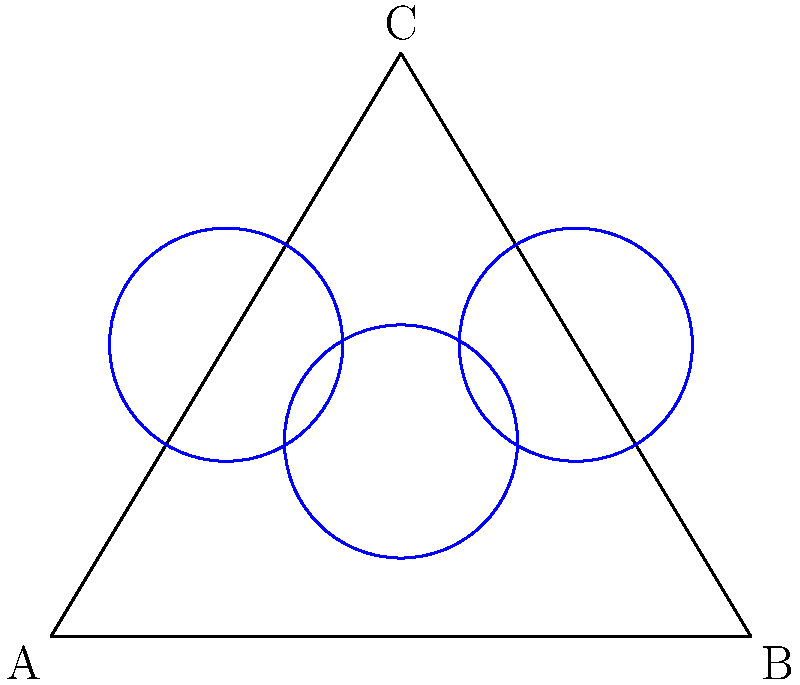In a software optimization problem, you need to place three identical circular processing units within an equilateral triangular server rack for maximum efficiency. Given that the side length of the triangular rack is 6 units, what is the maximum radius of each circular processing unit that can fit within the rack without overlapping? To solve this problem, we'll follow these steps:

1. Recognize that the optimal placement of three circles in an equilateral triangle is when each circle touches the other two and each touches two sides of the triangle.

2. Calculate the height of the equilateral triangle:
   $h = \sqrt{3} \cdot \frac{side}{2} = \sqrt{3} \cdot 3 = 3\sqrt{3}$

3. The centers of the circles form a smaller equilateral triangle. Let's call the distance from the center of this smaller triangle to its vertices $x$.

4. The radius of each circle, $r$, is equal to $x$.

5. The distance from the center of the smaller triangle to the side of the larger triangle is $h/3 = \sqrt{3}$.

6. Using the Pythagorean theorem:
   $x^2 + (\sqrt{3} - x)^2 = (3)^2$

7. Simplify:
   $x^2 + 3 - 2\sqrt{3}x + x^2 = 9$
   $2x^2 - 2\sqrt{3}x - 6 = 0$

8. Solve this quadratic equation:
   $x = \frac{2\sqrt{3} \pm \sqrt{12 + 48}}{4} = \frac{\sqrt{3} \pm \sqrt{15}}{2}$

9. Take the positive solution:
   $x = \frac{\sqrt{3} + \sqrt{15}}{2}$

10. This $x$ is equal to the radius $r$ of each circle.

11. Simplify:
    $r = \frac{\sqrt{3} + \sqrt{15}}{2} = \frac{\sqrt{3} + \sqrt{3}\sqrt{5}}{2} = \frac{\sqrt{3}(1 + \sqrt{5})}{2}$
Answer: $\frac{\sqrt{3}(1 + \sqrt{5})}{2}$ units 